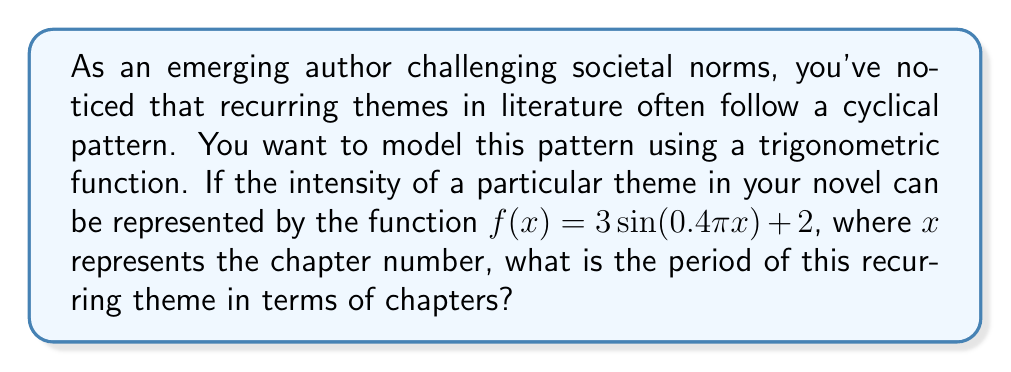Could you help me with this problem? To find the period of the recurring theme, we need to analyze the given trigonometric function:

$f(x) = 3\sin(0.4\pi x) + 2$

The general form of a sine function is:

$f(x) = A\sin(Bx) + C$

where:
- $A$ is the amplitude
- $B$ is the angular frequency
- $C$ is the vertical shift

In our case:
- $A = 3$
- $B = 0.4\pi$
- $C = 2$

The period of a sine function is given by the formula:

$$\text{Period} = \frac{2\pi}{|B|}$$

Substituting our value for $B$:

$$\text{Period} = \frac{2\pi}{|0.4\pi|}$$

Simplifying:

$$\text{Period} = \frac{2\pi}{0.4\pi} = \frac{2}{0.4} = 5$$

Therefore, the period of the recurring theme is 5 chapters.

This means that the theme will complete one full cycle every 5 chapters, challenging readers to recognize and reflect on its repetition and evolution throughout the novel.
Answer: 5 chapters 